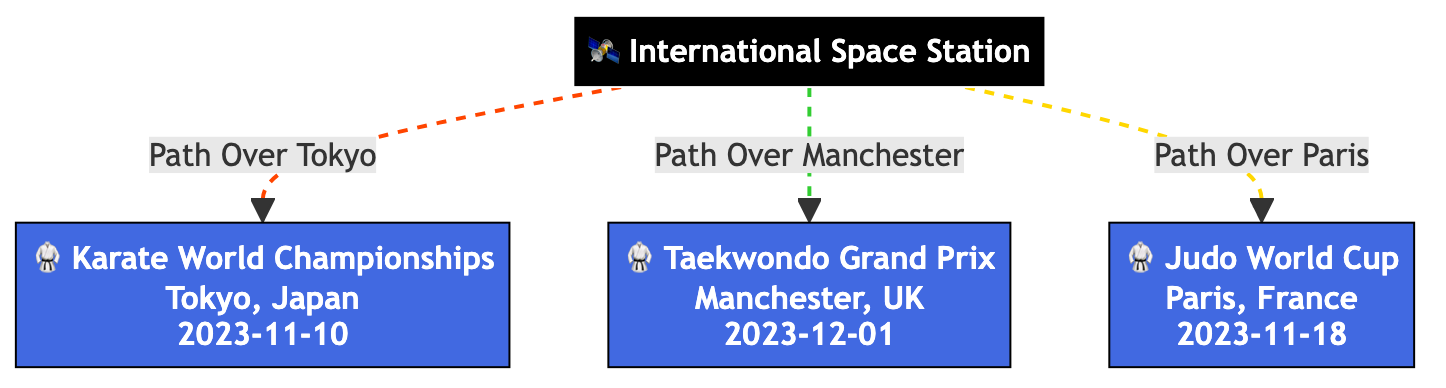What's the total number of major martial arts events shown in the diagram? The diagram displays three major martial arts events: the Karate World Championships, the Taekwondo Grand Prix, and the Judo World Cup.
Answer: 3 What event takes place in Tokyo, Japan? The Karate World Championships is the event scheduled to take place in Tokyo, Japan, on November 10, 2023.
Answer: Karate World Championships Which city is associated with the Taekwondo Grand Prix? The Taekwondo Grand Prix is linked to Manchester, UK, as indicated in the diagram.
Answer: Manchester What color represents the spacecraft in the diagram? The spacecraft, represented by the International Space Station, is in black.
Answer: black Which event occurs last in the timeline, based on the dates shown? The Taekwondo Grand Prix is the last event in the timeline, occurring on December 1, 2023, after the Judo World Cup and Karate World Championships.
Answer: Taekwondo Grand Prix Explain the type of link that connects the ISS to the Judo World Cup. The link between the ISS and the Judo World Cup is represented by a solid line styled with a golden color and a dashed pattern, indicating the unique pathway that the ISS takes over that event.
Answer: dashed golden line How many distinct paths from the ISS are illustrated in the diagram? There are three distinct paths leading from the ISS to each of the martial arts events shown in the diagram.
Answer: 3 Which event is closest to the date of the next event after the Karate World Championships? The Judo World Cup occurs next after the Karate World Championships, scheduled for November 18, 2023.
Answer: Judo World Cup What type of diagram is this and what is its primary focus? This is an Astronomy Diagram primarily focusing on tracking the path of the International Space Station over major martial arts tournaments and events.
Answer: Astronomy Diagram 